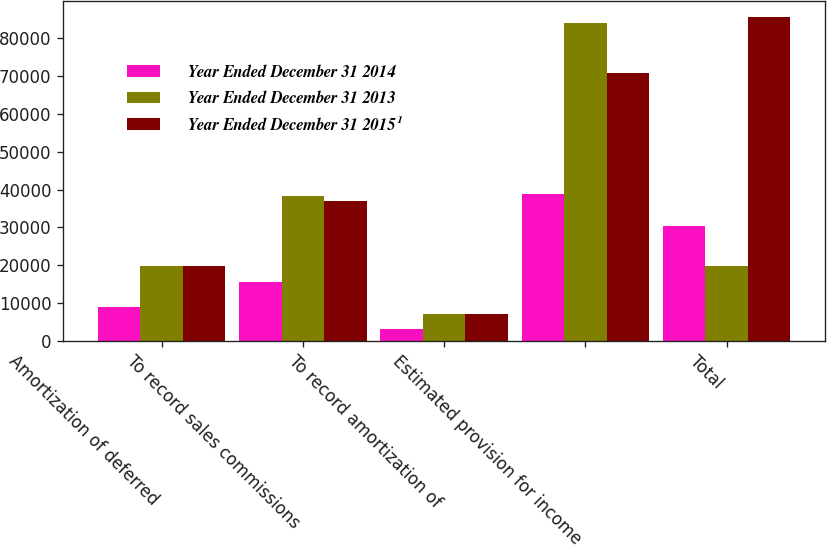<chart> <loc_0><loc_0><loc_500><loc_500><stacked_bar_chart><ecel><fcel>Amortization of deferred<fcel>To record sales commissions<fcel>To record amortization of<fcel>Estimated provision for income<fcel>Total<nl><fcel>Year Ended December 31 2014<fcel>8887<fcel>15470<fcel>3126<fcel>38721<fcel>30390<nl><fcel>Year Ended December 31 2013<fcel>19900<fcel>38352<fcel>7000<fcel>84106<fcel>19900<nl><fcel>Year Ended December 31 2015¹<fcel>19900<fcel>36969<fcel>7000<fcel>70749<fcel>85551<nl></chart> 